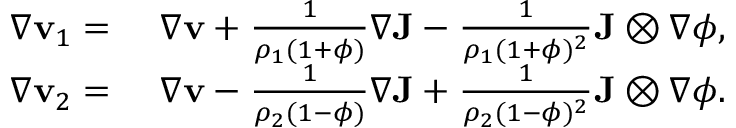<formula> <loc_0><loc_0><loc_500><loc_500>\begin{array} { r l } { \nabla v _ { 1 } = } & { \nabla v + \frac { 1 } { \rho _ { 1 } ( 1 + \phi ) } \nabla J - \frac { 1 } { \rho _ { 1 } ( 1 + \phi ) ^ { 2 } } J \otimes \nabla \phi , } \\ { \nabla v _ { 2 } = } & { \nabla v - \frac { 1 } { \rho _ { 2 } ( 1 - \phi ) } \nabla J + \frac { 1 } { \rho _ { 2 } ( 1 - \phi ) ^ { 2 } } J \otimes \nabla \phi . } \end{array}</formula> 